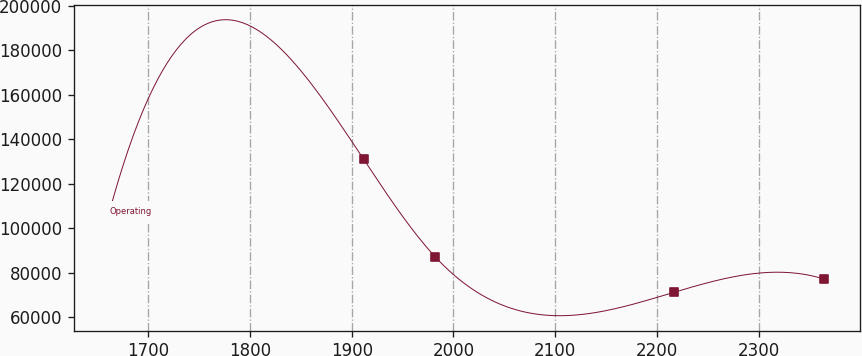Convert chart to OTSL. <chart><loc_0><loc_0><loc_500><loc_500><line_chart><ecel><fcel>Operating<nl><fcel>1661.98<fcel>107409<nl><fcel>1911.63<fcel>131068<nl><fcel>1981.82<fcel>87221.6<nl><fcel>2216.61<fcel>71133<nl><fcel>2363.92<fcel>77126.5<nl></chart> 